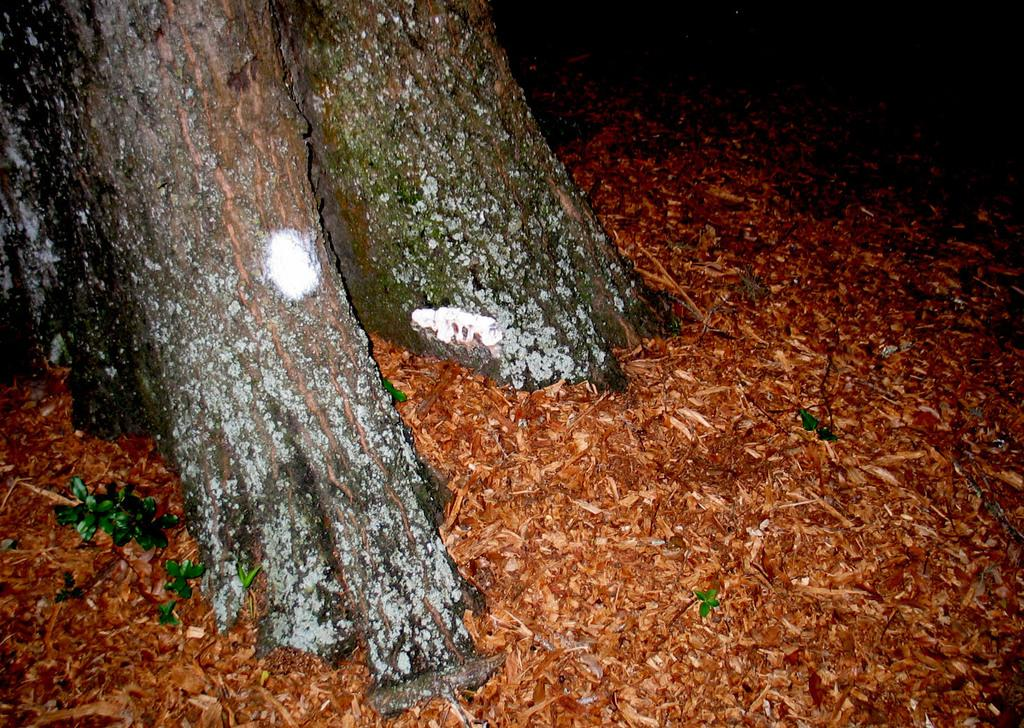What type of vegetation is on the left side of the image? There are trees on the left side of the image. Can you describe the taste of the rabbit in the image? There is no rabbit present in the image, so it is not possible to describe its taste. 